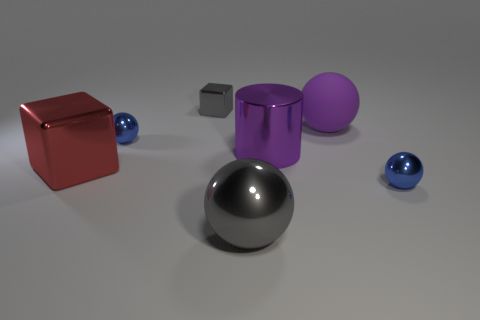Subtract 1 spheres. How many spheres are left? 3 Add 1 cylinders. How many objects exist? 8 Subtract all cylinders. How many objects are left? 6 Add 1 small gray matte cylinders. How many small gray matte cylinders exist? 1 Subtract 0 green cubes. How many objects are left? 7 Subtract all blue spheres. Subtract all red shiny things. How many objects are left? 4 Add 6 big rubber things. How many big rubber things are left? 7 